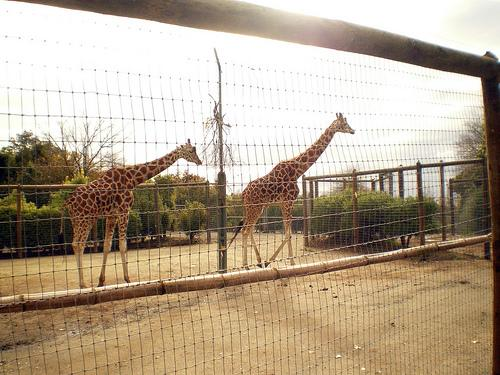Please, kindly describe to me the environment where the main subjects dwell in the picture. The giraffes are located in an outdoor pen with wooden fencing, a few green bushes inside, and ground covered with dirt, rocks, and some bamboo. Provide a single sentence summary of the main objects and actions taking place in the image. Two giraffes with long necks and spotted bodies are in a pen with wooden fencing, surrounded by green bushes, dirt, and rocks on the ground. In a casual tone, tell me what's happening with the animals in the picture and their environment. There are two giraffes just chilling in their pen, hanging out near some green bushes and dirt, all inside a wooden fence. Can you tell me the key highlights of what's happening with the living subjects and surrounds in the picture? Two giraffes stand within a pen enclosed by a wooden fence, surrounded by an earthy landscape filled with dirt, rocks, and lush green bushes. Now, in simple terms, mention the environment and the main features of the living beings pictured. Outdoor area with two spotted giraffes in a pen, wooden fence, green bushes, and ground with dirt and rocks. Quickly mention the main subjects in the image and what seems to be happening with them. Two giraffes are standing in a pen, with one appearing to walk and the other having its head bent down, surrounded by wooden fencing and green bushes. Adopting an academic style, elucidate the most significant attributes and actions of the living organisms present in the image. This image presents a giraffe habitat featuring two giraffes with extended necks and spotted characteristics, engaged in locomotion and feeding behavior within an enclosure bounded by wooden fencing and embellished with flora. In an artistic manner, elaborate on the essence of the visualized content of the image. Under a bright sky, two majestic giraffes dwell within their habitat, gracefully walking and gracefully lowering their heads amidst wooden fencing and verdant greenery. Describe the image by focusing on the primary living subjects and their physical environment. Two giraffes with long necks and spots are settled inside a pen surrounded by wooden fencing, alongside green bushes, a bamboo-filled landscape, and a ground covered with dirt and rocks. Using concise language, point out the setting and the main living creatures seen in the image. Outdoor giraffe pen with wooden fence, green bushes, and two giraffes, one walking and one with its head down. 